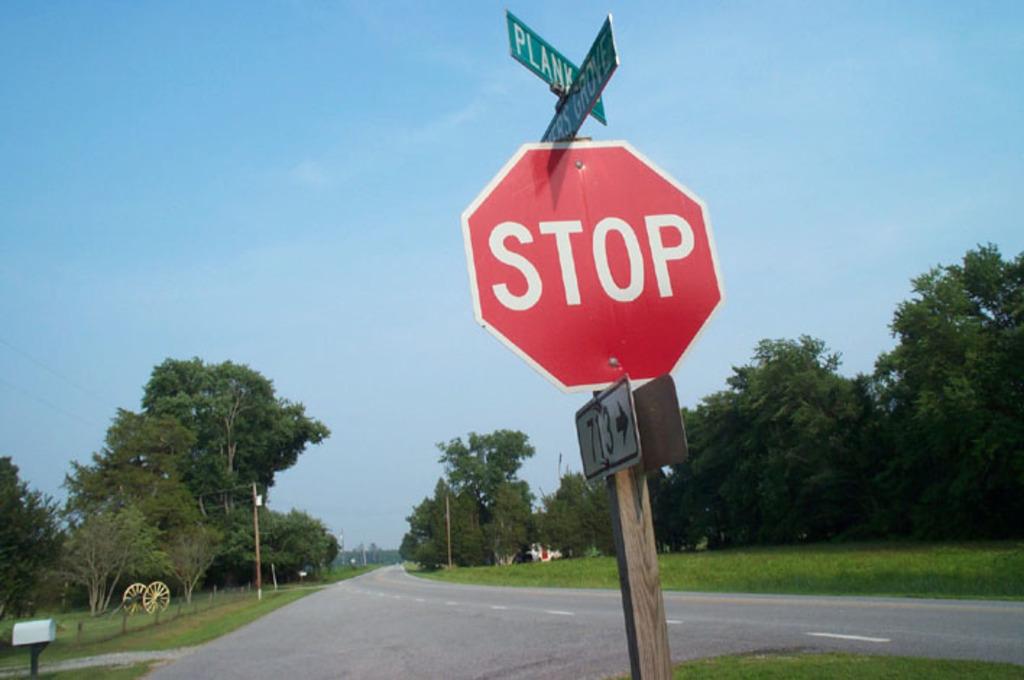What kind of sign is shown here?
Provide a short and direct response. Stop. 